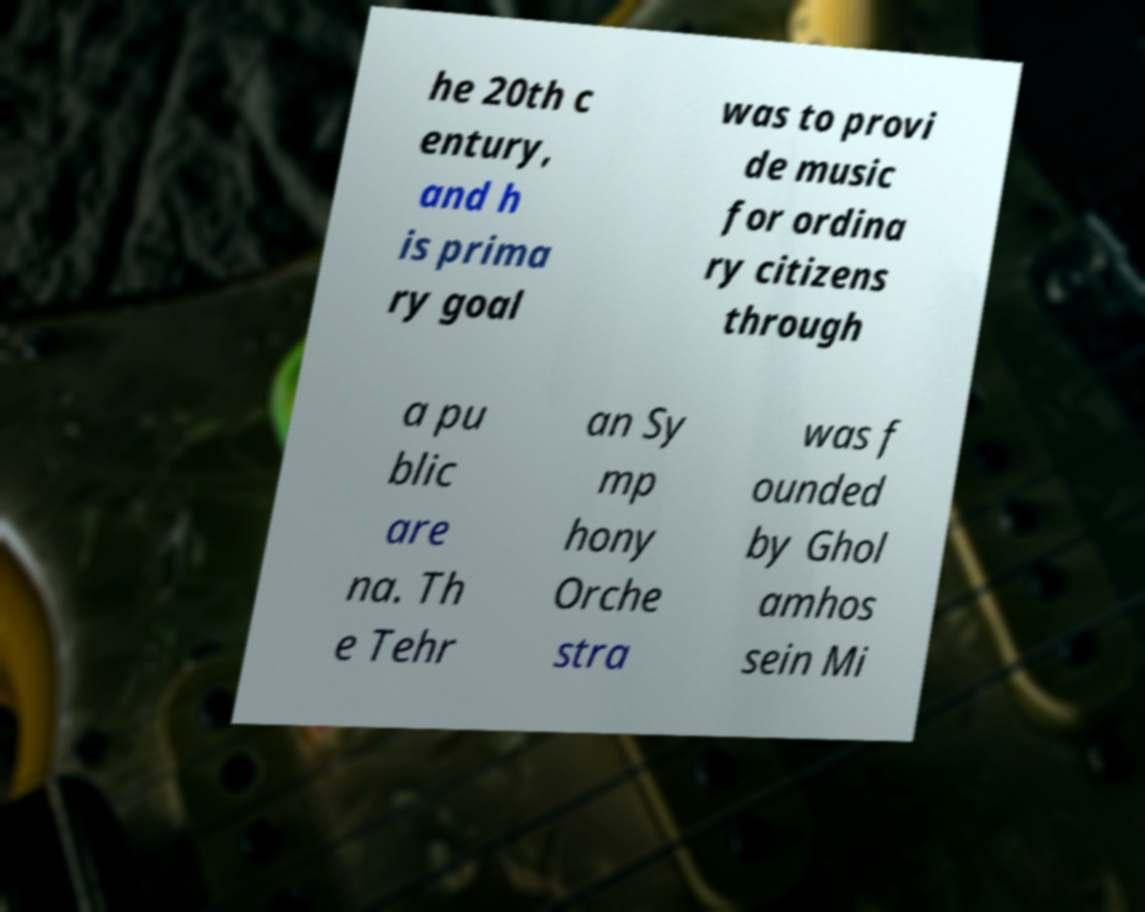I need the written content from this picture converted into text. Can you do that? he 20th c entury, and h is prima ry goal was to provi de music for ordina ry citizens through a pu blic are na. Th e Tehr an Sy mp hony Orche stra was f ounded by Ghol amhos sein Mi 